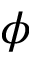Convert formula to latex. <formula><loc_0><loc_0><loc_500><loc_500>\phi</formula> 